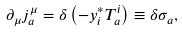Convert formula to latex. <formula><loc_0><loc_0><loc_500><loc_500>\partial _ { \mu } j _ { a } ^ { \mu } = \delta \left ( - y _ { i } ^ { * } T _ { a } ^ { i } \right ) \equiv \delta \sigma _ { a } ,</formula> 